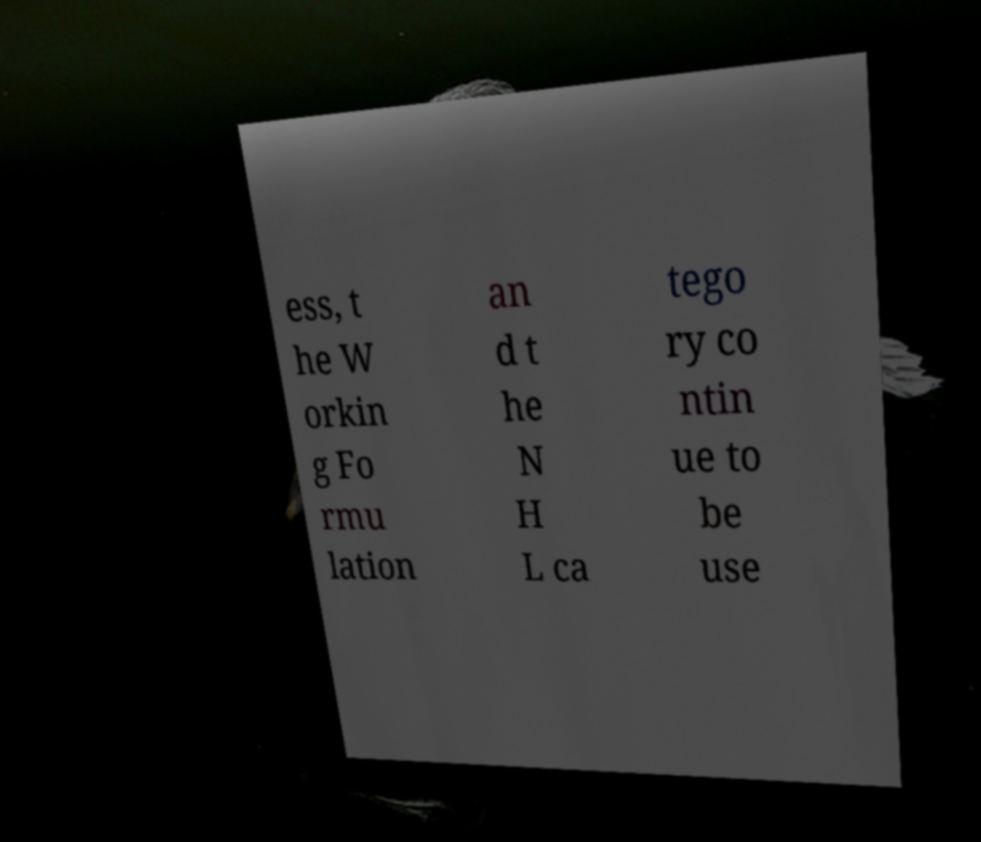Can you accurately transcribe the text from the provided image for me? ess, t he W orkin g Fo rmu lation an d t he N H L ca tego ry co ntin ue to be use 